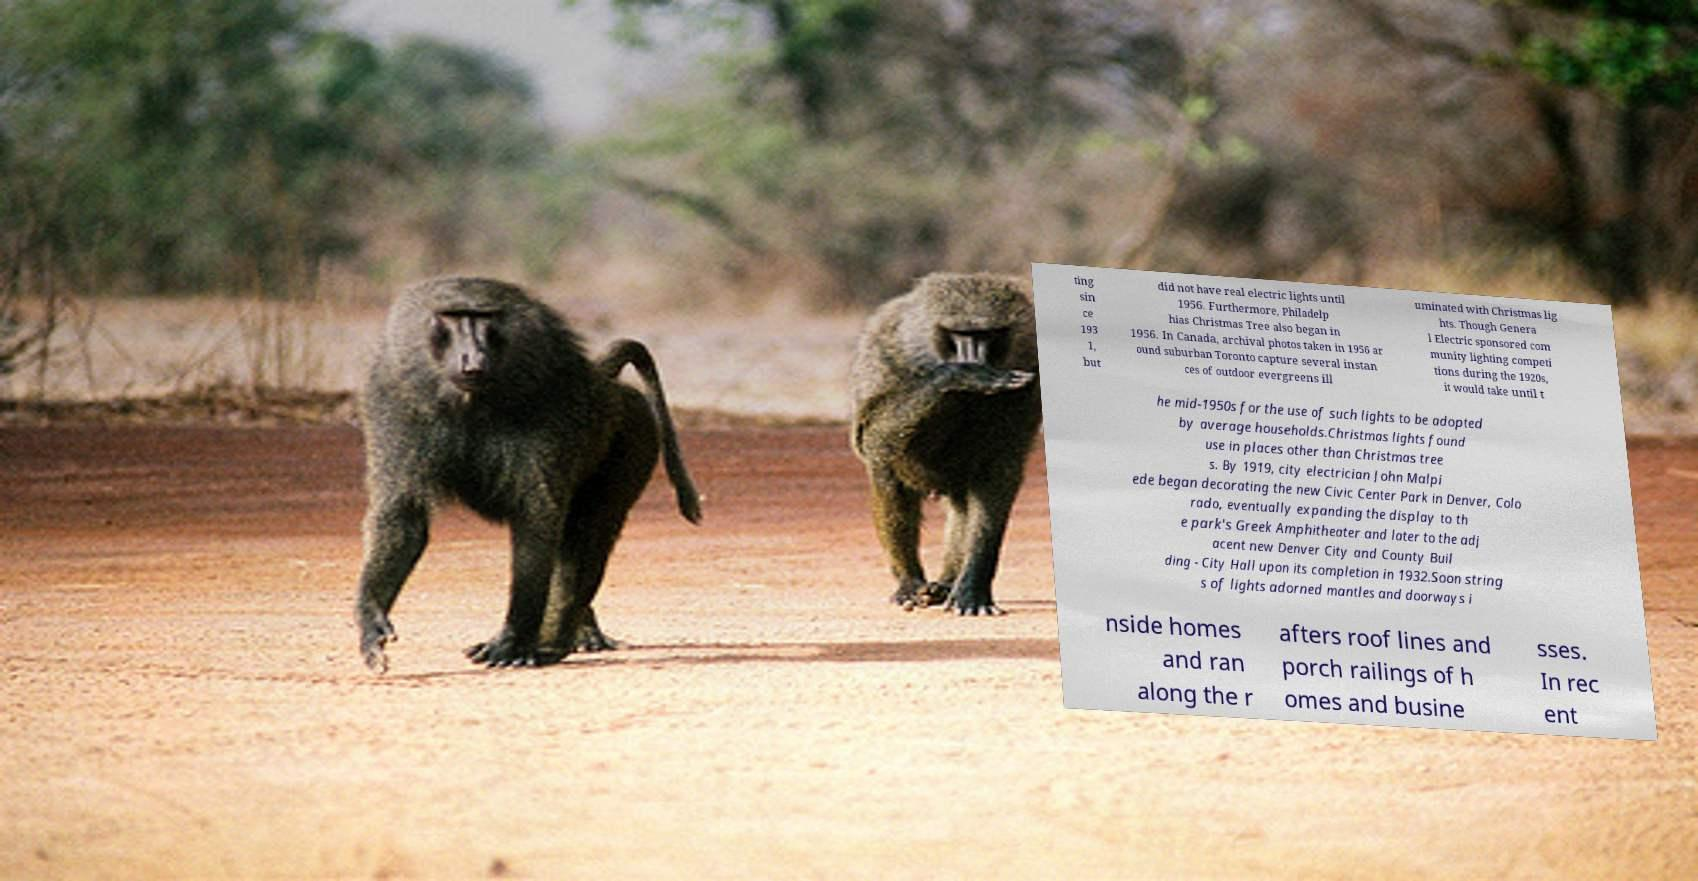Can you accurately transcribe the text from the provided image for me? ting sin ce 193 1, but did not have real electric lights until 1956. Furthermore, Philadelp hias Christmas Tree also began in 1956. In Canada, archival photos taken in 1956 ar ound suburban Toronto capture several instan ces of outdoor evergreens ill uminated with Christmas lig hts. Though Genera l Electric sponsored com munity lighting competi tions during the 1920s, it would take until t he mid-1950s for the use of such lights to be adopted by average households.Christmas lights found use in places other than Christmas tree s. By 1919, city electrician John Malpi ede began decorating the new Civic Center Park in Denver, Colo rado, eventually expanding the display to th e park's Greek Amphitheater and later to the adj acent new Denver City and County Buil ding - City Hall upon its completion in 1932.Soon string s of lights adorned mantles and doorways i nside homes and ran along the r afters roof lines and porch railings of h omes and busine sses. In rec ent 